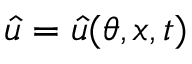<formula> <loc_0><loc_0><loc_500><loc_500>\hat { u } = \hat { u } ( \theta , x , t )</formula> 